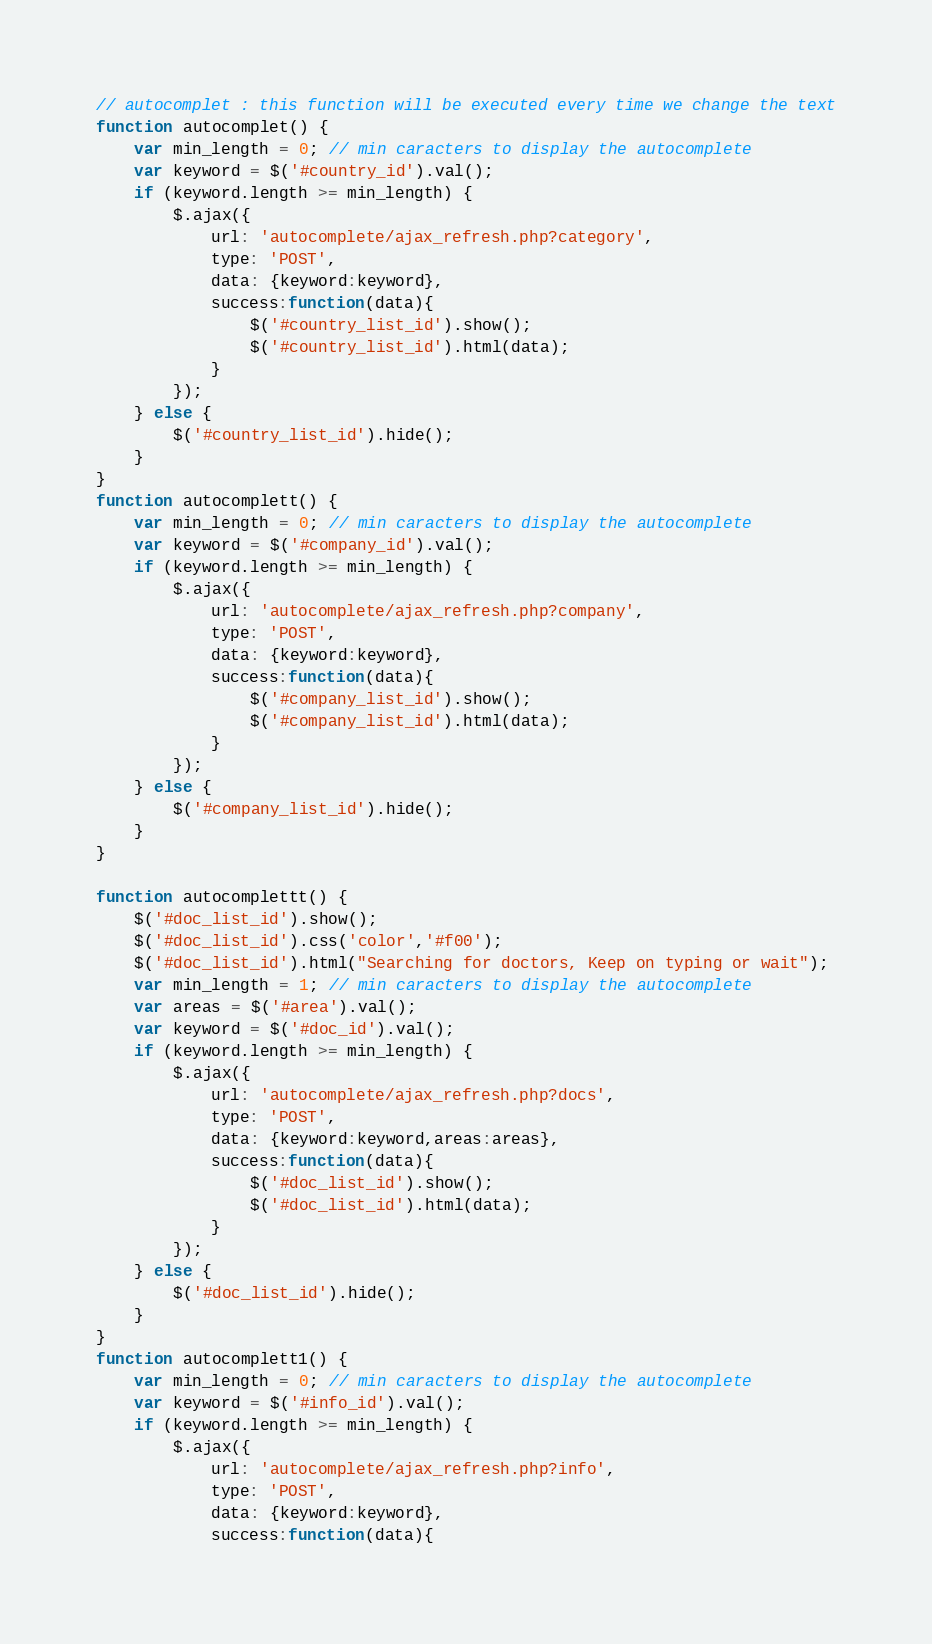<code> <loc_0><loc_0><loc_500><loc_500><_JavaScript_>// autocomplet : this function will be executed every time we change the text
function autocomplet() {
	var min_length = 0; // min caracters to display the autocomplete
	var keyword = $('#country_id').val();
	if (keyword.length >= min_length) {
		$.ajax({
			url: 'autocomplete/ajax_refresh.php?category',
			type: 'POST',
			data: {keyword:keyword},
			success:function(data){
				$('#country_list_id').show();
				$('#country_list_id').html(data);
			}
		});
	} else {
		$('#country_list_id').hide();
	}
}
function autocomplett() {
	var min_length = 0; // min caracters to display the autocomplete
	var keyword = $('#company_id').val();
	if (keyword.length >= min_length) {
		$.ajax({
			url: 'autocomplete/ajax_refresh.php?company',
			type: 'POST',
			data: {keyword:keyword},
			success:function(data){
				$('#company_list_id').show();
				$('#company_list_id').html(data);
			}
		});
	} else {
		$('#company_list_id').hide();
	}
}

function autocomplettt() {
	$('#doc_list_id').show();
	$('#doc_list_id').css('color','#f00');
	$('#doc_list_id').html("Searching for doctors, Keep on typing or wait");
	var min_length = 1; // min caracters to display the autocomplete
	var areas = $('#area').val();
	var keyword = $('#doc_id').val();
	if (keyword.length >= min_length) {
		$.ajax({
			url: 'autocomplete/ajax_refresh.php?docs',
			type: 'POST',
			data: {keyword:keyword,areas:areas},
			success:function(data){
				$('#doc_list_id').show();
				$('#doc_list_id').html(data);
			}
		});
	} else {
		$('#doc_list_id').hide();
	}
}
function autocomplett1() {	
	var min_length = 0; // min caracters to display the autocomplete
	var keyword = $('#info_id').val();
	if (keyword.length >= min_length) {
		$.ajax({
			url: 'autocomplete/ajax_refresh.php?info',
			type: 'POST',
			data: {keyword:keyword},
			success:function(data){</code> 